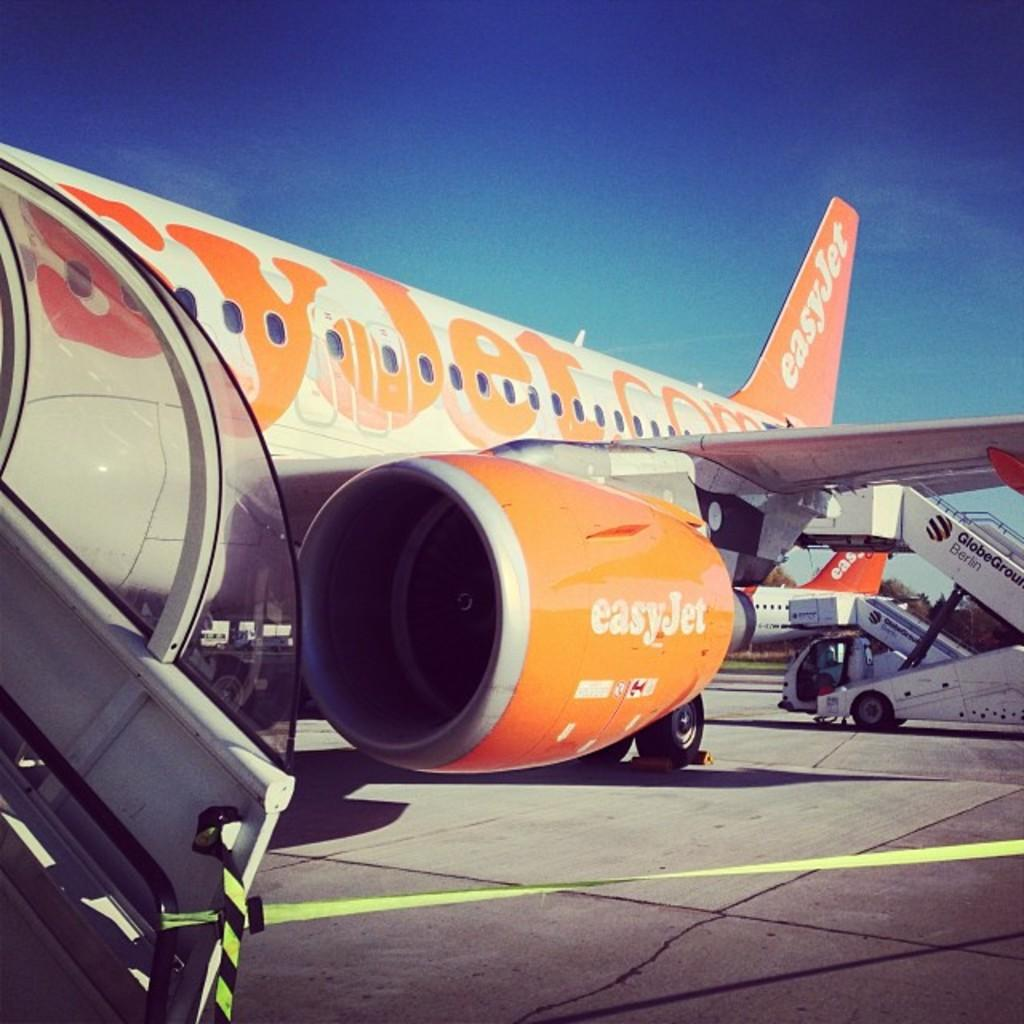<image>
Give a short and clear explanation of the subsequent image. An Easy Jet plane stands idle on an airport runway. 